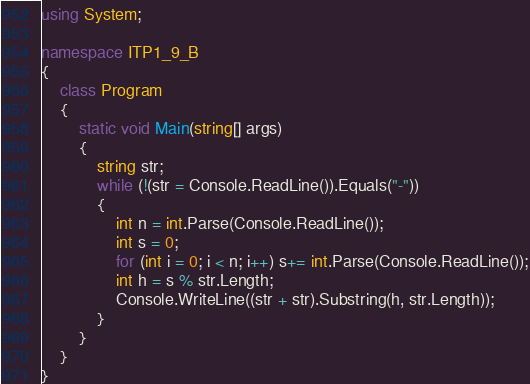<code> <loc_0><loc_0><loc_500><loc_500><_C#_>using System;

namespace ITP1_9_B
{
    class Program
    {
        static void Main(string[] args)
        {
            string str;
            while (!(str = Console.ReadLine()).Equals("-"))
            {
                int n = int.Parse(Console.ReadLine());
                int s = 0;
                for (int i = 0; i < n; i++) s+= int.Parse(Console.ReadLine());
                int h = s % str.Length;
                Console.WriteLine((str + str).Substring(h, str.Length));
            }
        }
    }
}</code> 